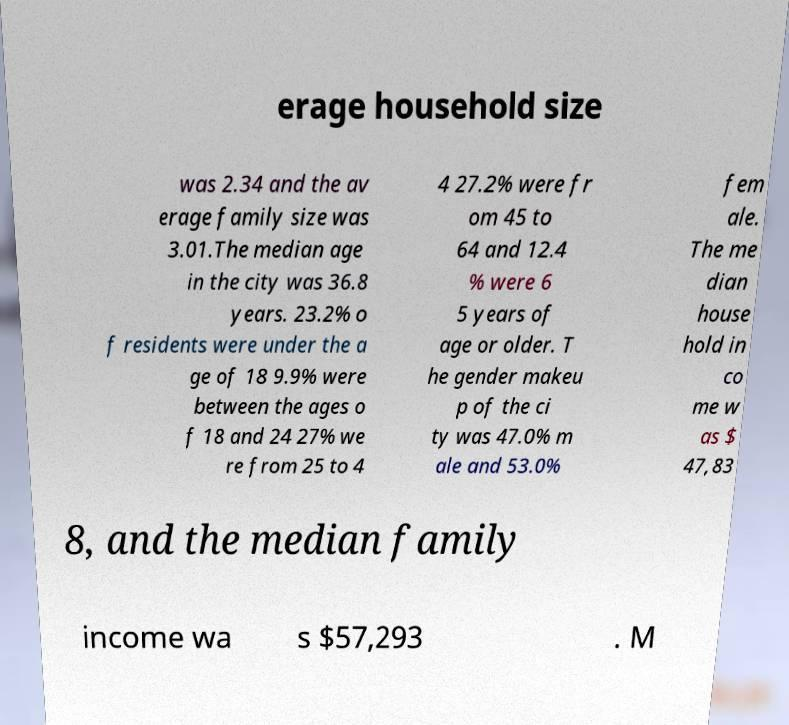Could you assist in decoding the text presented in this image and type it out clearly? erage household size was 2.34 and the av erage family size was 3.01.The median age in the city was 36.8 years. 23.2% o f residents were under the a ge of 18 9.9% were between the ages o f 18 and 24 27% we re from 25 to 4 4 27.2% were fr om 45 to 64 and 12.4 % were 6 5 years of age or older. T he gender makeu p of the ci ty was 47.0% m ale and 53.0% fem ale. The me dian house hold in co me w as $ 47,83 8, and the median family income wa s $57,293 . M 